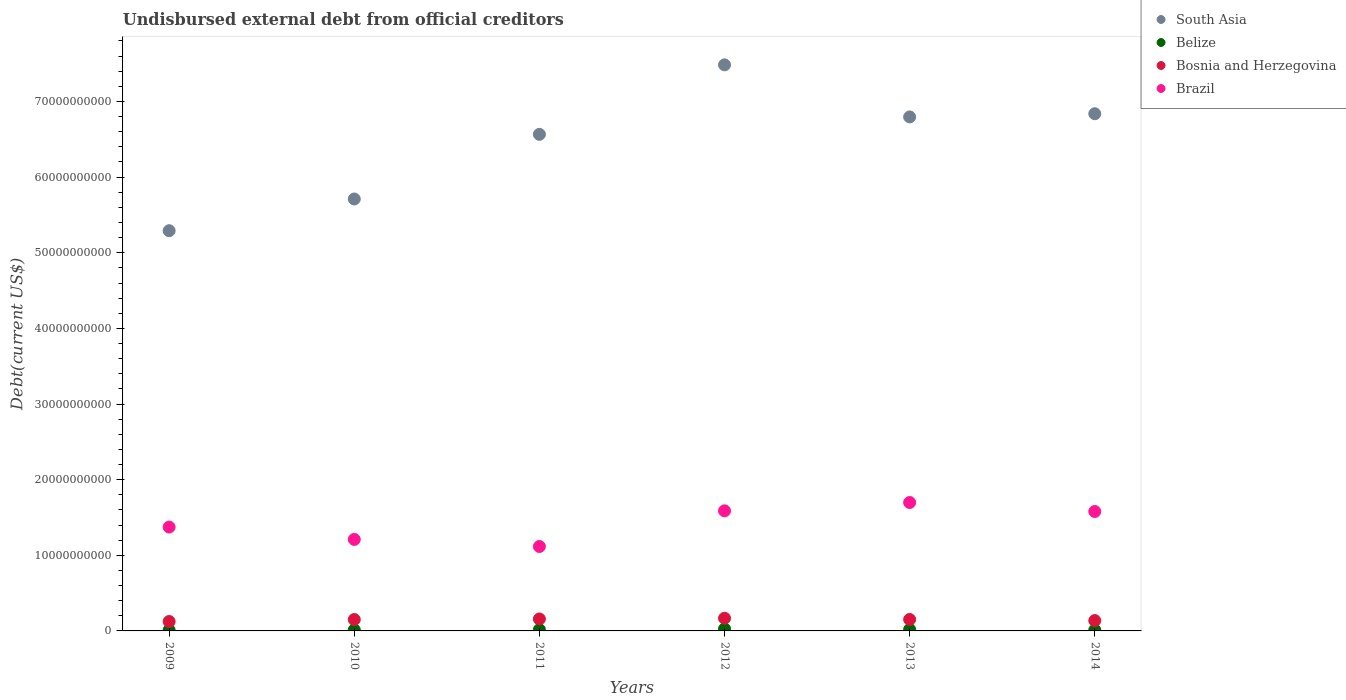What is the total debt in South Asia in 2009?
Give a very brief answer. 5.29e+1. Across all years, what is the maximum total debt in Brazil?
Keep it short and to the point. 1.70e+1. Across all years, what is the minimum total debt in South Asia?
Your answer should be very brief. 5.29e+1. In which year was the total debt in Bosnia and Herzegovina minimum?
Your answer should be very brief. 2009. What is the total total debt in Brazil in the graph?
Your response must be concise. 8.56e+1. What is the difference between the total debt in Brazil in 2013 and that in 2014?
Provide a succinct answer. 1.19e+09. What is the difference between the total debt in South Asia in 2014 and the total debt in Brazil in 2012?
Your answer should be very brief. 5.25e+1. What is the average total debt in Brazil per year?
Provide a short and direct response. 1.43e+1. In the year 2011, what is the difference between the total debt in Bosnia and Herzegovina and total debt in South Asia?
Make the answer very short. -6.41e+1. What is the ratio of the total debt in Belize in 2011 to that in 2014?
Provide a short and direct response. 1.45. Is the total debt in Brazil in 2011 less than that in 2013?
Your answer should be compact. Yes. What is the difference between the highest and the second highest total debt in Belize?
Your answer should be compact. 7.61e+07. What is the difference between the highest and the lowest total debt in Brazil?
Offer a terse response. 5.81e+09. In how many years, is the total debt in Belize greater than the average total debt in Belize taken over all years?
Provide a short and direct response. 3. Is the sum of the total debt in Brazil in 2010 and 2013 greater than the maximum total debt in South Asia across all years?
Ensure brevity in your answer.  No. Is it the case that in every year, the sum of the total debt in Brazil and total debt in South Asia  is greater than the sum of total debt in Belize and total debt in Bosnia and Herzegovina?
Your answer should be very brief. No. Is it the case that in every year, the sum of the total debt in Brazil and total debt in Bosnia and Herzegovina  is greater than the total debt in South Asia?
Your answer should be very brief. No. Is the total debt in South Asia strictly greater than the total debt in Brazil over the years?
Offer a terse response. Yes. Is the total debt in Belize strictly less than the total debt in Brazil over the years?
Your response must be concise. Yes. What is the difference between two consecutive major ticks on the Y-axis?
Give a very brief answer. 1.00e+1. Does the graph contain grids?
Provide a short and direct response. No. Where does the legend appear in the graph?
Provide a succinct answer. Top right. How are the legend labels stacked?
Give a very brief answer. Vertical. What is the title of the graph?
Your answer should be very brief. Undisbursed external debt from official creditors. What is the label or title of the Y-axis?
Your response must be concise. Debt(current US$). What is the Debt(current US$) of South Asia in 2009?
Offer a terse response. 5.29e+1. What is the Debt(current US$) of Belize in 2009?
Give a very brief answer. 9.97e+07. What is the Debt(current US$) in Bosnia and Herzegovina in 2009?
Offer a very short reply. 1.25e+09. What is the Debt(current US$) in Brazil in 2009?
Give a very brief answer. 1.37e+1. What is the Debt(current US$) of South Asia in 2010?
Provide a succinct answer. 5.71e+1. What is the Debt(current US$) in Belize in 2010?
Offer a very short reply. 1.43e+08. What is the Debt(current US$) of Bosnia and Herzegovina in 2010?
Your answer should be very brief. 1.50e+09. What is the Debt(current US$) in Brazil in 2010?
Ensure brevity in your answer.  1.21e+1. What is the Debt(current US$) in South Asia in 2011?
Provide a short and direct response. 6.57e+1. What is the Debt(current US$) in Belize in 2011?
Offer a terse response. 1.74e+08. What is the Debt(current US$) in Bosnia and Herzegovina in 2011?
Offer a terse response. 1.58e+09. What is the Debt(current US$) in Brazil in 2011?
Your response must be concise. 1.12e+1. What is the Debt(current US$) in South Asia in 2012?
Offer a very short reply. 7.48e+1. What is the Debt(current US$) of Belize in 2012?
Make the answer very short. 2.68e+08. What is the Debt(current US$) in Bosnia and Herzegovina in 2012?
Give a very brief answer. 1.68e+09. What is the Debt(current US$) of Brazil in 2012?
Keep it short and to the point. 1.59e+1. What is the Debt(current US$) in South Asia in 2013?
Your answer should be very brief. 6.80e+1. What is the Debt(current US$) of Belize in 2013?
Offer a very short reply. 1.92e+08. What is the Debt(current US$) of Bosnia and Herzegovina in 2013?
Offer a terse response. 1.51e+09. What is the Debt(current US$) of Brazil in 2013?
Your answer should be very brief. 1.70e+1. What is the Debt(current US$) of South Asia in 2014?
Ensure brevity in your answer.  6.84e+1. What is the Debt(current US$) of Belize in 2014?
Give a very brief answer. 1.20e+08. What is the Debt(current US$) of Bosnia and Herzegovina in 2014?
Your answer should be compact. 1.37e+09. What is the Debt(current US$) in Brazil in 2014?
Your response must be concise. 1.58e+1. Across all years, what is the maximum Debt(current US$) of South Asia?
Keep it short and to the point. 7.48e+1. Across all years, what is the maximum Debt(current US$) in Belize?
Your answer should be very brief. 2.68e+08. Across all years, what is the maximum Debt(current US$) of Bosnia and Herzegovina?
Provide a short and direct response. 1.68e+09. Across all years, what is the maximum Debt(current US$) of Brazil?
Provide a short and direct response. 1.70e+1. Across all years, what is the minimum Debt(current US$) of South Asia?
Offer a very short reply. 5.29e+1. Across all years, what is the minimum Debt(current US$) of Belize?
Offer a very short reply. 9.97e+07. Across all years, what is the minimum Debt(current US$) of Bosnia and Herzegovina?
Provide a succinct answer. 1.25e+09. Across all years, what is the minimum Debt(current US$) of Brazil?
Offer a very short reply. 1.12e+1. What is the total Debt(current US$) in South Asia in the graph?
Offer a very short reply. 3.87e+11. What is the total Debt(current US$) in Belize in the graph?
Offer a very short reply. 9.96e+08. What is the total Debt(current US$) of Bosnia and Herzegovina in the graph?
Give a very brief answer. 8.89e+09. What is the total Debt(current US$) in Brazil in the graph?
Keep it short and to the point. 8.56e+1. What is the difference between the Debt(current US$) of South Asia in 2009 and that in 2010?
Your response must be concise. -4.19e+09. What is the difference between the Debt(current US$) of Belize in 2009 and that in 2010?
Provide a succinct answer. -4.32e+07. What is the difference between the Debt(current US$) in Bosnia and Herzegovina in 2009 and that in 2010?
Your answer should be very brief. -2.59e+08. What is the difference between the Debt(current US$) of Brazil in 2009 and that in 2010?
Offer a very short reply. 1.63e+09. What is the difference between the Debt(current US$) of South Asia in 2009 and that in 2011?
Give a very brief answer. -1.27e+1. What is the difference between the Debt(current US$) of Belize in 2009 and that in 2011?
Provide a short and direct response. -7.43e+07. What is the difference between the Debt(current US$) in Bosnia and Herzegovina in 2009 and that in 2011?
Provide a short and direct response. -3.35e+08. What is the difference between the Debt(current US$) in Brazil in 2009 and that in 2011?
Your answer should be compact. 2.57e+09. What is the difference between the Debt(current US$) in South Asia in 2009 and that in 2012?
Ensure brevity in your answer.  -2.19e+1. What is the difference between the Debt(current US$) of Belize in 2009 and that in 2012?
Give a very brief answer. -1.68e+08. What is the difference between the Debt(current US$) of Bosnia and Herzegovina in 2009 and that in 2012?
Ensure brevity in your answer.  -4.30e+08. What is the difference between the Debt(current US$) in Brazil in 2009 and that in 2012?
Keep it short and to the point. -2.15e+09. What is the difference between the Debt(current US$) of South Asia in 2009 and that in 2013?
Give a very brief answer. -1.50e+1. What is the difference between the Debt(current US$) in Belize in 2009 and that in 2013?
Keep it short and to the point. -9.19e+07. What is the difference between the Debt(current US$) of Bosnia and Herzegovina in 2009 and that in 2013?
Provide a succinct answer. -2.68e+08. What is the difference between the Debt(current US$) in Brazil in 2009 and that in 2013?
Provide a short and direct response. -3.25e+09. What is the difference between the Debt(current US$) in South Asia in 2009 and that in 2014?
Give a very brief answer. -1.55e+1. What is the difference between the Debt(current US$) of Belize in 2009 and that in 2014?
Keep it short and to the point. -2.00e+07. What is the difference between the Debt(current US$) of Bosnia and Herzegovina in 2009 and that in 2014?
Make the answer very short. -1.23e+08. What is the difference between the Debt(current US$) in Brazil in 2009 and that in 2014?
Your answer should be compact. -2.06e+09. What is the difference between the Debt(current US$) in South Asia in 2010 and that in 2011?
Your answer should be compact. -8.55e+09. What is the difference between the Debt(current US$) of Belize in 2010 and that in 2011?
Your response must be concise. -3.12e+07. What is the difference between the Debt(current US$) in Bosnia and Herzegovina in 2010 and that in 2011?
Provide a short and direct response. -7.62e+07. What is the difference between the Debt(current US$) of Brazil in 2010 and that in 2011?
Offer a very short reply. 9.36e+08. What is the difference between the Debt(current US$) in South Asia in 2010 and that in 2012?
Give a very brief answer. -1.77e+1. What is the difference between the Debt(current US$) in Belize in 2010 and that in 2012?
Provide a short and direct response. -1.25e+08. What is the difference between the Debt(current US$) in Bosnia and Herzegovina in 2010 and that in 2012?
Offer a terse response. -1.71e+08. What is the difference between the Debt(current US$) of Brazil in 2010 and that in 2012?
Ensure brevity in your answer.  -3.78e+09. What is the difference between the Debt(current US$) of South Asia in 2010 and that in 2013?
Give a very brief answer. -1.09e+1. What is the difference between the Debt(current US$) in Belize in 2010 and that in 2013?
Your answer should be very brief. -4.87e+07. What is the difference between the Debt(current US$) in Bosnia and Herzegovina in 2010 and that in 2013?
Ensure brevity in your answer.  -9.34e+06. What is the difference between the Debt(current US$) in Brazil in 2010 and that in 2013?
Keep it short and to the point. -4.88e+09. What is the difference between the Debt(current US$) in South Asia in 2010 and that in 2014?
Your response must be concise. -1.13e+1. What is the difference between the Debt(current US$) of Belize in 2010 and that in 2014?
Make the answer very short. 2.32e+07. What is the difference between the Debt(current US$) in Bosnia and Herzegovina in 2010 and that in 2014?
Your answer should be very brief. 1.36e+08. What is the difference between the Debt(current US$) in Brazil in 2010 and that in 2014?
Keep it short and to the point. -3.69e+09. What is the difference between the Debt(current US$) of South Asia in 2011 and that in 2012?
Keep it short and to the point. -9.19e+09. What is the difference between the Debt(current US$) in Belize in 2011 and that in 2012?
Give a very brief answer. -9.36e+07. What is the difference between the Debt(current US$) in Bosnia and Herzegovina in 2011 and that in 2012?
Your answer should be very brief. -9.48e+07. What is the difference between the Debt(current US$) in Brazil in 2011 and that in 2012?
Your answer should be compact. -4.72e+09. What is the difference between the Debt(current US$) in South Asia in 2011 and that in 2013?
Your response must be concise. -2.30e+09. What is the difference between the Debt(current US$) in Belize in 2011 and that in 2013?
Give a very brief answer. -1.75e+07. What is the difference between the Debt(current US$) in Bosnia and Herzegovina in 2011 and that in 2013?
Your answer should be very brief. 6.68e+07. What is the difference between the Debt(current US$) of Brazil in 2011 and that in 2013?
Give a very brief answer. -5.81e+09. What is the difference between the Debt(current US$) in South Asia in 2011 and that in 2014?
Give a very brief answer. -2.72e+09. What is the difference between the Debt(current US$) of Belize in 2011 and that in 2014?
Keep it short and to the point. 5.44e+07. What is the difference between the Debt(current US$) of Bosnia and Herzegovina in 2011 and that in 2014?
Make the answer very short. 2.12e+08. What is the difference between the Debt(current US$) of Brazil in 2011 and that in 2014?
Your response must be concise. -4.63e+09. What is the difference between the Debt(current US$) in South Asia in 2012 and that in 2013?
Provide a succinct answer. 6.89e+09. What is the difference between the Debt(current US$) of Belize in 2012 and that in 2013?
Make the answer very short. 7.61e+07. What is the difference between the Debt(current US$) in Bosnia and Herzegovina in 2012 and that in 2013?
Offer a very short reply. 1.62e+08. What is the difference between the Debt(current US$) of Brazil in 2012 and that in 2013?
Your answer should be very brief. -1.10e+09. What is the difference between the Debt(current US$) in South Asia in 2012 and that in 2014?
Ensure brevity in your answer.  6.46e+09. What is the difference between the Debt(current US$) in Belize in 2012 and that in 2014?
Offer a terse response. 1.48e+08. What is the difference between the Debt(current US$) of Bosnia and Herzegovina in 2012 and that in 2014?
Provide a succinct answer. 3.07e+08. What is the difference between the Debt(current US$) in Brazil in 2012 and that in 2014?
Your response must be concise. 8.95e+07. What is the difference between the Debt(current US$) of South Asia in 2013 and that in 2014?
Offer a terse response. -4.22e+08. What is the difference between the Debt(current US$) in Belize in 2013 and that in 2014?
Your answer should be very brief. 7.19e+07. What is the difference between the Debt(current US$) of Bosnia and Herzegovina in 2013 and that in 2014?
Make the answer very short. 1.45e+08. What is the difference between the Debt(current US$) of Brazil in 2013 and that in 2014?
Provide a succinct answer. 1.19e+09. What is the difference between the Debt(current US$) of South Asia in 2009 and the Debt(current US$) of Belize in 2010?
Ensure brevity in your answer.  5.28e+1. What is the difference between the Debt(current US$) of South Asia in 2009 and the Debt(current US$) of Bosnia and Herzegovina in 2010?
Keep it short and to the point. 5.14e+1. What is the difference between the Debt(current US$) of South Asia in 2009 and the Debt(current US$) of Brazil in 2010?
Provide a succinct answer. 4.08e+1. What is the difference between the Debt(current US$) of Belize in 2009 and the Debt(current US$) of Bosnia and Herzegovina in 2010?
Your response must be concise. -1.40e+09. What is the difference between the Debt(current US$) in Belize in 2009 and the Debt(current US$) in Brazil in 2010?
Provide a succinct answer. -1.20e+1. What is the difference between the Debt(current US$) in Bosnia and Herzegovina in 2009 and the Debt(current US$) in Brazil in 2010?
Provide a succinct answer. -1.09e+1. What is the difference between the Debt(current US$) in South Asia in 2009 and the Debt(current US$) in Belize in 2011?
Keep it short and to the point. 5.27e+1. What is the difference between the Debt(current US$) in South Asia in 2009 and the Debt(current US$) in Bosnia and Herzegovina in 2011?
Your response must be concise. 5.13e+1. What is the difference between the Debt(current US$) in South Asia in 2009 and the Debt(current US$) in Brazil in 2011?
Ensure brevity in your answer.  4.18e+1. What is the difference between the Debt(current US$) of Belize in 2009 and the Debt(current US$) of Bosnia and Herzegovina in 2011?
Offer a terse response. -1.48e+09. What is the difference between the Debt(current US$) in Belize in 2009 and the Debt(current US$) in Brazil in 2011?
Your response must be concise. -1.11e+1. What is the difference between the Debt(current US$) of Bosnia and Herzegovina in 2009 and the Debt(current US$) of Brazil in 2011?
Your answer should be compact. -9.92e+09. What is the difference between the Debt(current US$) in South Asia in 2009 and the Debt(current US$) in Belize in 2012?
Offer a terse response. 5.26e+1. What is the difference between the Debt(current US$) of South Asia in 2009 and the Debt(current US$) of Bosnia and Herzegovina in 2012?
Ensure brevity in your answer.  5.12e+1. What is the difference between the Debt(current US$) in South Asia in 2009 and the Debt(current US$) in Brazil in 2012?
Provide a succinct answer. 3.70e+1. What is the difference between the Debt(current US$) in Belize in 2009 and the Debt(current US$) in Bosnia and Herzegovina in 2012?
Your answer should be very brief. -1.58e+09. What is the difference between the Debt(current US$) in Belize in 2009 and the Debt(current US$) in Brazil in 2012?
Your response must be concise. -1.58e+1. What is the difference between the Debt(current US$) of Bosnia and Herzegovina in 2009 and the Debt(current US$) of Brazil in 2012?
Provide a succinct answer. -1.46e+1. What is the difference between the Debt(current US$) of South Asia in 2009 and the Debt(current US$) of Belize in 2013?
Make the answer very short. 5.27e+1. What is the difference between the Debt(current US$) of South Asia in 2009 and the Debt(current US$) of Bosnia and Herzegovina in 2013?
Your answer should be very brief. 5.14e+1. What is the difference between the Debt(current US$) in South Asia in 2009 and the Debt(current US$) in Brazil in 2013?
Keep it short and to the point. 3.59e+1. What is the difference between the Debt(current US$) of Belize in 2009 and the Debt(current US$) of Bosnia and Herzegovina in 2013?
Give a very brief answer. -1.41e+09. What is the difference between the Debt(current US$) in Belize in 2009 and the Debt(current US$) in Brazil in 2013?
Your answer should be compact. -1.69e+1. What is the difference between the Debt(current US$) in Bosnia and Herzegovina in 2009 and the Debt(current US$) in Brazil in 2013?
Give a very brief answer. -1.57e+1. What is the difference between the Debt(current US$) in South Asia in 2009 and the Debt(current US$) in Belize in 2014?
Keep it short and to the point. 5.28e+1. What is the difference between the Debt(current US$) in South Asia in 2009 and the Debt(current US$) in Bosnia and Herzegovina in 2014?
Provide a short and direct response. 5.15e+1. What is the difference between the Debt(current US$) of South Asia in 2009 and the Debt(current US$) of Brazil in 2014?
Give a very brief answer. 3.71e+1. What is the difference between the Debt(current US$) in Belize in 2009 and the Debt(current US$) in Bosnia and Herzegovina in 2014?
Give a very brief answer. -1.27e+09. What is the difference between the Debt(current US$) of Belize in 2009 and the Debt(current US$) of Brazil in 2014?
Ensure brevity in your answer.  -1.57e+1. What is the difference between the Debt(current US$) of Bosnia and Herzegovina in 2009 and the Debt(current US$) of Brazil in 2014?
Your answer should be very brief. -1.45e+1. What is the difference between the Debt(current US$) in South Asia in 2010 and the Debt(current US$) in Belize in 2011?
Make the answer very short. 5.69e+1. What is the difference between the Debt(current US$) of South Asia in 2010 and the Debt(current US$) of Bosnia and Herzegovina in 2011?
Your answer should be very brief. 5.55e+1. What is the difference between the Debt(current US$) in South Asia in 2010 and the Debt(current US$) in Brazil in 2011?
Offer a terse response. 4.59e+1. What is the difference between the Debt(current US$) in Belize in 2010 and the Debt(current US$) in Bosnia and Herzegovina in 2011?
Offer a terse response. -1.44e+09. What is the difference between the Debt(current US$) in Belize in 2010 and the Debt(current US$) in Brazil in 2011?
Ensure brevity in your answer.  -1.10e+1. What is the difference between the Debt(current US$) of Bosnia and Herzegovina in 2010 and the Debt(current US$) of Brazil in 2011?
Keep it short and to the point. -9.66e+09. What is the difference between the Debt(current US$) of South Asia in 2010 and the Debt(current US$) of Belize in 2012?
Give a very brief answer. 5.68e+1. What is the difference between the Debt(current US$) in South Asia in 2010 and the Debt(current US$) in Bosnia and Herzegovina in 2012?
Your answer should be very brief. 5.54e+1. What is the difference between the Debt(current US$) of South Asia in 2010 and the Debt(current US$) of Brazil in 2012?
Give a very brief answer. 4.12e+1. What is the difference between the Debt(current US$) of Belize in 2010 and the Debt(current US$) of Bosnia and Herzegovina in 2012?
Offer a terse response. -1.53e+09. What is the difference between the Debt(current US$) in Belize in 2010 and the Debt(current US$) in Brazil in 2012?
Keep it short and to the point. -1.57e+1. What is the difference between the Debt(current US$) of Bosnia and Herzegovina in 2010 and the Debt(current US$) of Brazil in 2012?
Provide a short and direct response. -1.44e+1. What is the difference between the Debt(current US$) in South Asia in 2010 and the Debt(current US$) in Belize in 2013?
Ensure brevity in your answer.  5.69e+1. What is the difference between the Debt(current US$) of South Asia in 2010 and the Debt(current US$) of Bosnia and Herzegovina in 2013?
Ensure brevity in your answer.  5.56e+1. What is the difference between the Debt(current US$) of South Asia in 2010 and the Debt(current US$) of Brazil in 2013?
Your answer should be compact. 4.01e+1. What is the difference between the Debt(current US$) of Belize in 2010 and the Debt(current US$) of Bosnia and Herzegovina in 2013?
Your answer should be compact. -1.37e+09. What is the difference between the Debt(current US$) of Belize in 2010 and the Debt(current US$) of Brazil in 2013?
Your answer should be very brief. -1.68e+1. What is the difference between the Debt(current US$) of Bosnia and Herzegovina in 2010 and the Debt(current US$) of Brazil in 2013?
Give a very brief answer. -1.55e+1. What is the difference between the Debt(current US$) of South Asia in 2010 and the Debt(current US$) of Belize in 2014?
Offer a very short reply. 5.70e+1. What is the difference between the Debt(current US$) in South Asia in 2010 and the Debt(current US$) in Bosnia and Herzegovina in 2014?
Keep it short and to the point. 5.57e+1. What is the difference between the Debt(current US$) of South Asia in 2010 and the Debt(current US$) of Brazil in 2014?
Provide a short and direct response. 4.13e+1. What is the difference between the Debt(current US$) in Belize in 2010 and the Debt(current US$) in Bosnia and Herzegovina in 2014?
Ensure brevity in your answer.  -1.23e+09. What is the difference between the Debt(current US$) of Belize in 2010 and the Debt(current US$) of Brazil in 2014?
Provide a short and direct response. -1.56e+1. What is the difference between the Debt(current US$) in Bosnia and Herzegovina in 2010 and the Debt(current US$) in Brazil in 2014?
Your response must be concise. -1.43e+1. What is the difference between the Debt(current US$) in South Asia in 2011 and the Debt(current US$) in Belize in 2012?
Provide a succinct answer. 6.54e+1. What is the difference between the Debt(current US$) of South Asia in 2011 and the Debt(current US$) of Bosnia and Herzegovina in 2012?
Offer a very short reply. 6.40e+1. What is the difference between the Debt(current US$) in South Asia in 2011 and the Debt(current US$) in Brazil in 2012?
Provide a short and direct response. 4.98e+1. What is the difference between the Debt(current US$) of Belize in 2011 and the Debt(current US$) of Bosnia and Herzegovina in 2012?
Your answer should be compact. -1.50e+09. What is the difference between the Debt(current US$) of Belize in 2011 and the Debt(current US$) of Brazil in 2012?
Your answer should be compact. -1.57e+1. What is the difference between the Debt(current US$) of Bosnia and Herzegovina in 2011 and the Debt(current US$) of Brazil in 2012?
Keep it short and to the point. -1.43e+1. What is the difference between the Debt(current US$) of South Asia in 2011 and the Debt(current US$) of Belize in 2013?
Provide a short and direct response. 6.55e+1. What is the difference between the Debt(current US$) in South Asia in 2011 and the Debt(current US$) in Bosnia and Herzegovina in 2013?
Your response must be concise. 6.41e+1. What is the difference between the Debt(current US$) in South Asia in 2011 and the Debt(current US$) in Brazil in 2013?
Ensure brevity in your answer.  4.87e+1. What is the difference between the Debt(current US$) in Belize in 2011 and the Debt(current US$) in Bosnia and Herzegovina in 2013?
Your answer should be compact. -1.34e+09. What is the difference between the Debt(current US$) in Belize in 2011 and the Debt(current US$) in Brazil in 2013?
Provide a short and direct response. -1.68e+1. What is the difference between the Debt(current US$) in Bosnia and Herzegovina in 2011 and the Debt(current US$) in Brazil in 2013?
Provide a short and direct response. -1.54e+1. What is the difference between the Debt(current US$) of South Asia in 2011 and the Debt(current US$) of Belize in 2014?
Ensure brevity in your answer.  6.55e+1. What is the difference between the Debt(current US$) of South Asia in 2011 and the Debt(current US$) of Bosnia and Herzegovina in 2014?
Give a very brief answer. 6.43e+1. What is the difference between the Debt(current US$) of South Asia in 2011 and the Debt(current US$) of Brazil in 2014?
Your response must be concise. 4.99e+1. What is the difference between the Debt(current US$) of Belize in 2011 and the Debt(current US$) of Bosnia and Herzegovina in 2014?
Offer a terse response. -1.19e+09. What is the difference between the Debt(current US$) in Belize in 2011 and the Debt(current US$) in Brazil in 2014?
Offer a terse response. -1.56e+1. What is the difference between the Debt(current US$) of Bosnia and Herzegovina in 2011 and the Debt(current US$) of Brazil in 2014?
Your response must be concise. -1.42e+1. What is the difference between the Debt(current US$) of South Asia in 2012 and the Debt(current US$) of Belize in 2013?
Ensure brevity in your answer.  7.47e+1. What is the difference between the Debt(current US$) in South Asia in 2012 and the Debt(current US$) in Bosnia and Herzegovina in 2013?
Keep it short and to the point. 7.33e+1. What is the difference between the Debt(current US$) of South Asia in 2012 and the Debt(current US$) of Brazil in 2013?
Keep it short and to the point. 5.79e+1. What is the difference between the Debt(current US$) in Belize in 2012 and the Debt(current US$) in Bosnia and Herzegovina in 2013?
Provide a short and direct response. -1.25e+09. What is the difference between the Debt(current US$) of Belize in 2012 and the Debt(current US$) of Brazil in 2013?
Keep it short and to the point. -1.67e+1. What is the difference between the Debt(current US$) in Bosnia and Herzegovina in 2012 and the Debt(current US$) in Brazil in 2013?
Offer a very short reply. -1.53e+1. What is the difference between the Debt(current US$) of South Asia in 2012 and the Debt(current US$) of Belize in 2014?
Your answer should be very brief. 7.47e+1. What is the difference between the Debt(current US$) of South Asia in 2012 and the Debt(current US$) of Bosnia and Herzegovina in 2014?
Ensure brevity in your answer.  7.35e+1. What is the difference between the Debt(current US$) in South Asia in 2012 and the Debt(current US$) in Brazil in 2014?
Make the answer very short. 5.91e+1. What is the difference between the Debt(current US$) of Belize in 2012 and the Debt(current US$) of Bosnia and Herzegovina in 2014?
Keep it short and to the point. -1.10e+09. What is the difference between the Debt(current US$) of Belize in 2012 and the Debt(current US$) of Brazil in 2014?
Your answer should be compact. -1.55e+1. What is the difference between the Debt(current US$) in Bosnia and Herzegovina in 2012 and the Debt(current US$) in Brazil in 2014?
Your response must be concise. -1.41e+1. What is the difference between the Debt(current US$) of South Asia in 2013 and the Debt(current US$) of Belize in 2014?
Provide a short and direct response. 6.78e+1. What is the difference between the Debt(current US$) of South Asia in 2013 and the Debt(current US$) of Bosnia and Herzegovina in 2014?
Your response must be concise. 6.66e+1. What is the difference between the Debt(current US$) in South Asia in 2013 and the Debt(current US$) in Brazil in 2014?
Offer a very short reply. 5.22e+1. What is the difference between the Debt(current US$) in Belize in 2013 and the Debt(current US$) in Bosnia and Herzegovina in 2014?
Provide a succinct answer. -1.18e+09. What is the difference between the Debt(current US$) in Belize in 2013 and the Debt(current US$) in Brazil in 2014?
Provide a succinct answer. -1.56e+1. What is the difference between the Debt(current US$) in Bosnia and Herzegovina in 2013 and the Debt(current US$) in Brazil in 2014?
Give a very brief answer. -1.43e+1. What is the average Debt(current US$) of South Asia per year?
Offer a terse response. 6.45e+1. What is the average Debt(current US$) of Belize per year?
Offer a terse response. 1.66e+08. What is the average Debt(current US$) in Bosnia and Herzegovina per year?
Provide a short and direct response. 1.48e+09. What is the average Debt(current US$) of Brazil per year?
Provide a short and direct response. 1.43e+1. In the year 2009, what is the difference between the Debt(current US$) of South Asia and Debt(current US$) of Belize?
Offer a very short reply. 5.28e+1. In the year 2009, what is the difference between the Debt(current US$) in South Asia and Debt(current US$) in Bosnia and Herzegovina?
Offer a very short reply. 5.17e+1. In the year 2009, what is the difference between the Debt(current US$) of South Asia and Debt(current US$) of Brazil?
Give a very brief answer. 3.92e+1. In the year 2009, what is the difference between the Debt(current US$) in Belize and Debt(current US$) in Bosnia and Herzegovina?
Provide a short and direct response. -1.15e+09. In the year 2009, what is the difference between the Debt(current US$) of Belize and Debt(current US$) of Brazil?
Keep it short and to the point. -1.36e+1. In the year 2009, what is the difference between the Debt(current US$) in Bosnia and Herzegovina and Debt(current US$) in Brazil?
Your answer should be compact. -1.25e+1. In the year 2010, what is the difference between the Debt(current US$) of South Asia and Debt(current US$) of Belize?
Provide a succinct answer. 5.70e+1. In the year 2010, what is the difference between the Debt(current US$) in South Asia and Debt(current US$) in Bosnia and Herzegovina?
Offer a very short reply. 5.56e+1. In the year 2010, what is the difference between the Debt(current US$) in South Asia and Debt(current US$) in Brazil?
Your answer should be very brief. 4.50e+1. In the year 2010, what is the difference between the Debt(current US$) in Belize and Debt(current US$) in Bosnia and Herzegovina?
Your answer should be very brief. -1.36e+09. In the year 2010, what is the difference between the Debt(current US$) in Belize and Debt(current US$) in Brazil?
Keep it short and to the point. -1.20e+1. In the year 2010, what is the difference between the Debt(current US$) of Bosnia and Herzegovina and Debt(current US$) of Brazil?
Your answer should be compact. -1.06e+1. In the year 2011, what is the difference between the Debt(current US$) of South Asia and Debt(current US$) of Belize?
Provide a short and direct response. 6.55e+1. In the year 2011, what is the difference between the Debt(current US$) of South Asia and Debt(current US$) of Bosnia and Herzegovina?
Your answer should be compact. 6.41e+1. In the year 2011, what is the difference between the Debt(current US$) in South Asia and Debt(current US$) in Brazil?
Give a very brief answer. 5.45e+1. In the year 2011, what is the difference between the Debt(current US$) of Belize and Debt(current US$) of Bosnia and Herzegovina?
Your answer should be compact. -1.41e+09. In the year 2011, what is the difference between the Debt(current US$) of Belize and Debt(current US$) of Brazil?
Ensure brevity in your answer.  -1.10e+1. In the year 2011, what is the difference between the Debt(current US$) of Bosnia and Herzegovina and Debt(current US$) of Brazil?
Provide a short and direct response. -9.58e+09. In the year 2012, what is the difference between the Debt(current US$) of South Asia and Debt(current US$) of Belize?
Give a very brief answer. 7.46e+1. In the year 2012, what is the difference between the Debt(current US$) of South Asia and Debt(current US$) of Bosnia and Herzegovina?
Keep it short and to the point. 7.32e+1. In the year 2012, what is the difference between the Debt(current US$) in South Asia and Debt(current US$) in Brazil?
Keep it short and to the point. 5.90e+1. In the year 2012, what is the difference between the Debt(current US$) of Belize and Debt(current US$) of Bosnia and Herzegovina?
Give a very brief answer. -1.41e+09. In the year 2012, what is the difference between the Debt(current US$) of Belize and Debt(current US$) of Brazil?
Provide a short and direct response. -1.56e+1. In the year 2012, what is the difference between the Debt(current US$) of Bosnia and Herzegovina and Debt(current US$) of Brazil?
Your answer should be very brief. -1.42e+1. In the year 2013, what is the difference between the Debt(current US$) of South Asia and Debt(current US$) of Belize?
Offer a terse response. 6.78e+1. In the year 2013, what is the difference between the Debt(current US$) in South Asia and Debt(current US$) in Bosnia and Herzegovina?
Your answer should be compact. 6.64e+1. In the year 2013, what is the difference between the Debt(current US$) of South Asia and Debt(current US$) of Brazil?
Keep it short and to the point. 5.10e+1. In the year 2013, what is the difference between the Debt(current US$) of Belize and Debt(current US$) of Bosnia and Herzegovina?
Ensure brevity in your answer.  -1.32e+09. In the year 2013, what is the difference between the Debt(current US$) in Belize and Debt(current US$) in Brazil?
Offer a terse response. -1.68e+1. In the year 2013, what is the difference between the Debt(current US$) in Bosnia and Herzegovina and Debt(current US$) in Brazil?
Your answer should be very brief. -1.55e+1. In the year 2014, what is the difference between the Debt(current US$) of South Asia and Debt(current US$) of Belize?
Give a very brief answer. 6.83e+1. In the year 2014, what is the difference between the Debt(current US$) of South Asia and Debt(current US$) of Bosnia and Herzegovina?
Offer a very short reply. 6.70e+1. In the year 2014, what is the difference between the Debt(current US$) in South Asia and Debt(current US$) in Brazil?
Ensure brevity in your answer.  5.26e+1. In the year 2014, what is the difference between the Debt(current US$) in Belize and Debt(current US$) in Bosnia and Herzegovina?
Provide a succinct answer. -1.25e+09. In the year 2014, what is the difference between the Debt(current US$) in Belize and Debt(current US$) in Brazil?
Offer a very short reply. -1.57e+1. In the year 2014, what is the difference between the Debt(current US$) in Bosnia and Herzegovina and Debt(current US$) in Brazil?
Keep it short and to the point. -1.44e+1. What is the ratio of the Debt(current US$) in South Asia in 2009 to that in 2010?
Your answer should be very brief. 0.93. What is the ratio of the Debt(current US$) of Belize in 2009 to that in 2010?
Give a very brief answer. 0.7. What is the ratio of the Debt(current US$) in Bosnia and Herzegovina in 2009 to that in 2010?
Ensure brevity in your answer.  0.83. What is the ratio of the Debt(current US$) in Brazil in 2009 to that in 2010?
Give a very brief answer. 1.13. What is the ratio of the Debt(current US$) in South Asia in 2009 to that in 2011?
Your response must be concise. 0.81. What is the ratio of the Debt(current US$) in Belize in 2009 to that in 2011?
Offer a very short reply. 0.57. What is the ratio of the Debt(current US$) of Bosnia and Herzegovina in 2009 to that in 2011?
Provide a succinct answer. 0.79. What is the ratio of the Debt(current US$) in Brazil in 2009 to that in 2011?
Your answer should be very brief. 1.23. What is the ratio of the Debt(current US$) of South Asia in 2009 to that in 2012?
Ensure brevity in your answer.  0.71. What is the ratio of the Debt(current US$) of Belize in 2009 to that in 2012?
Ensure brevity in your answer.  0.37. What is the ratio of the Debt(current US$) in Bosnia and Herzegovina in 2009 to that in 2012?
Give a very brief answer. 0.74. What is the ratio of the Debt(current US$) of Brazil in 2009 to that in 2012?
Offer a very short reply. 0.86. What is the ratio of the Debt(current US$) in South Asia in 2009 to that in 2013?
Keep it short and to the point. 0.78. What is the ratio of the Debt(current US$) in Belize in 2009 to that in 2013?
Offer a very short reply. 0.52. What is the ratio of the Debt(current US$) of Bosnia and Herzegovina in 2009 to that in 2013?
Provide a short and direct response. 0.82. What is the ratio of the Debt(current US$) in Brazil in 2009 to that in 2013?
Your answer should be very brief. 0.81. What is the ratio of the Debt(current US$) in South Asia in 2009 to that in 2014?
Offer a very short reply. 0.77. What is the ratio of the Debt(current US$) in Belize in 2009 to that in 2014?
Keep it short and to the point. 0.83. What is the ratio of the Debt(current US$) of Bosnia and Herzegovina in 2009 to that in 2014?
Give a very brief answer. 0.91. What is the ratio of the Debt(current US$) in Brazil in 2009 to that in 2014?
Your answer should be compact. 0.87. What is the ratio of the Debt(current US$) in South Asia in 2010 to that in 2011?
Your answer should be very brief. 0.87. What is the ratio of the Debt(current US$) in Belize in 2010 to that in 2011?
Make the answer very short. 0.82. What is the ratio of the Debt(current US$) in Bosnia and Herzegovina in 2010 to that in 2011?
Keep it short and to the point. 0.95. What is the ratio of the Debt(current US$) in Brazil in 2010 to that in 2011?
Offer a very short reply. 1.08. What is the ratio of the Debt(current US$) of South Asia in 2010 to that in 2012?
Make the answer very short. 0.76. What is the ratio of the Debt(current US$) in Belize in 2010 to that in 2012?
Your response must be concise. 0.53. What is the ratio of the Debt(current US$) in Bosnia and Herzegovina in 2010 to that in 2012?
Provide a succinct answer. 0.9. What is the ratio of the Debt(current US$) in Brazil in 2010 to that in 2012?
Give a very brief answer. 0.76. What is the ratio of the Debt(current US$) in South Asia in 2010 to that in 2013?
Provide a short and direct response. 0.84. What is the ratio of the Debt(current US$) in Belize in 2010 to that in 2013?
Your answer should be very brief. 0.75. What is the ratio of the Debt(current US$) in Bosnia and Herzegovina in 2010 to that in 2013?
Make the answer very short. 0.99. What is the ratio of the Debt(current US$) in Brazil in 2010 to that in 2013?
Ensure brevity in your answer.  0.71. What is the ratio of the Debt(current US$) in South Asia in 2010 to that in 2014?
Provide a short and direct response. 0.84. What is the ratio of the Debt(current US$) of Belize in 2010 to that in 2014?
Offer a terse response. 1.19. What is the ratio of the Debt(current US$) in Bosnia and Herzegovina in 2010 to that in 2014?
Ensure brevity in your answer.  1.1. What is the ratio of the Debt(current US$) of Brazil in 2010 to that in 2014?
Provide a short and direct response. 0.77. What is the ratio of the Debt(current US$) of South Asia in 2011 to that in 2012?
Provide a short and direct response. 0.88. What is the ratio of the Debt(current US$) of Belize in 2011 to that in 2012?
Your answer should be very brief. 0.65. What is the ratio of the Debt(current US$) in Bosnia and Herzegovina in 2011 to that in 2012?
Offer a very short reply. 0.94. What is the ratio of the Debt(current US$) of Brazil in 2011 to that in 2012?
Make the answer very short. 0.7. What is the ratio of the Debt(current US$) in South Asia in 2011 to that in 2013?
Keep it short and to the point. 0.97. What is the ratio of the Debt(current US$) in Belize in 2011 to that in 2013?
Offer a very short reply. 0.91. What is the ratio of the Debt(current US$) in Bosnia and Herzegovina in 2011 to that in 2013?
Offer a terse response. 1.04. What is the ratio of the Debt(current US$) of Brazil in 2011 to that in 2013?
Your answer should be compact. 0.66. What is the ratio of the Debt(current US$) in South Asia in 2011 to that in 2014?
Your answer should be compact. 0.96. What is the ratio of the Debt(current US$) of Belize in 2011 to that in 2014?
Offer a very short reply. 1.45. What is the ratio of the Debt(current US$) of Bosnia and Herzegovina in 2011 to that in 2014?
Keep it short and to the point. 1.16. What is the ratio of the Debt(current US$) in Brazil in 2011 to that in 2014?
Your answer should be very brief. 0.71. What is the ratio of the Debt(current US$) of South Asia in 2012 to that in 2013?
Your answer should be compact. 1.1. What is the ratio of the Debt(current US$) in Belize in 2012 to that in 2013?
Provide a succinct answer. 1.4. What is the ratio of the Debt(current US$) in Bosnia and Herzegovina in 2012 to that in 2013?
Offer a terse response. 1.11. What is the ratio of the Debt(current US$) in Brazil in 2012 to that in 2013?
Offer a very short reply. 0.94. What is the ratio of the Debt(current US$) in South Asia in 2012 to that in 2014?
Keep it short and to the point. 1.09. What is the ratio of the Debt(current US$) of Belize in 2012 to that in 2014?
Give a very brief answer. 2.24. What is the ratio of the Debt(current US$) in Bosnia and Herzegovina in 2012 to that in 2014?
Offer a very short reply. 1.22. What is the ratio of the Debt(current US$) in Belize in 2013 to that in 2014?
Provide a short and direct response. 1.6. What is the ratio of the Debt(current US$) in Bosnia and Herzegovina in 2013 to that in 2014?
Offer a terse response. 1.11. What is the ratio of the Debt(current US$) in Brazil in 2013 to that in 2014?
Ensure brevity in your answer.  1.08. What is the difference between the highest and the second highest Debt(current US$) in South Asia?
Give a very brief answer. 6.46e+09. What is the difference between the highest and the second highest Debt(current US$) of Belize?
Your answer should be compact. 7.61e+07. What is the difference between the highest and the second highest Debt(current US$) in Bosnia and Herzegovina?
Your answer should be compact. 9.48e+07. What is the difference between the highest and the second highest Debt(current US$) in Brazil?
Your answer should be compact. 1.10e+09. What is the difference between the highest and the lowest Debt(current US$) in South Asia?
Keep it short and to the point. 2.19e+1. What is the difference between the highest and the lowest Debt(current US$) in Belize?
Give a very brief answer. 1.68e+08. What is the difference between the highest and the lowest Debt(current US$) in Bosnia and Herzegovina?
Make the answer very short. 4.30e+08. What is the difference between the highest and the lowest Debt(current US$) in Brazil?
Your response must be concise. 5.81e+09. 